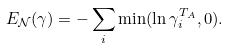Convert formula to latex. <formula><loc_0><loc_0><loc_500><loc_500>E _ { \mathcal { N } } ( \gamma ) = - \sum _ { i } \min ( \ln \gamma _ { i } ^ { T _ { A } } , 0 ) .</formula> 